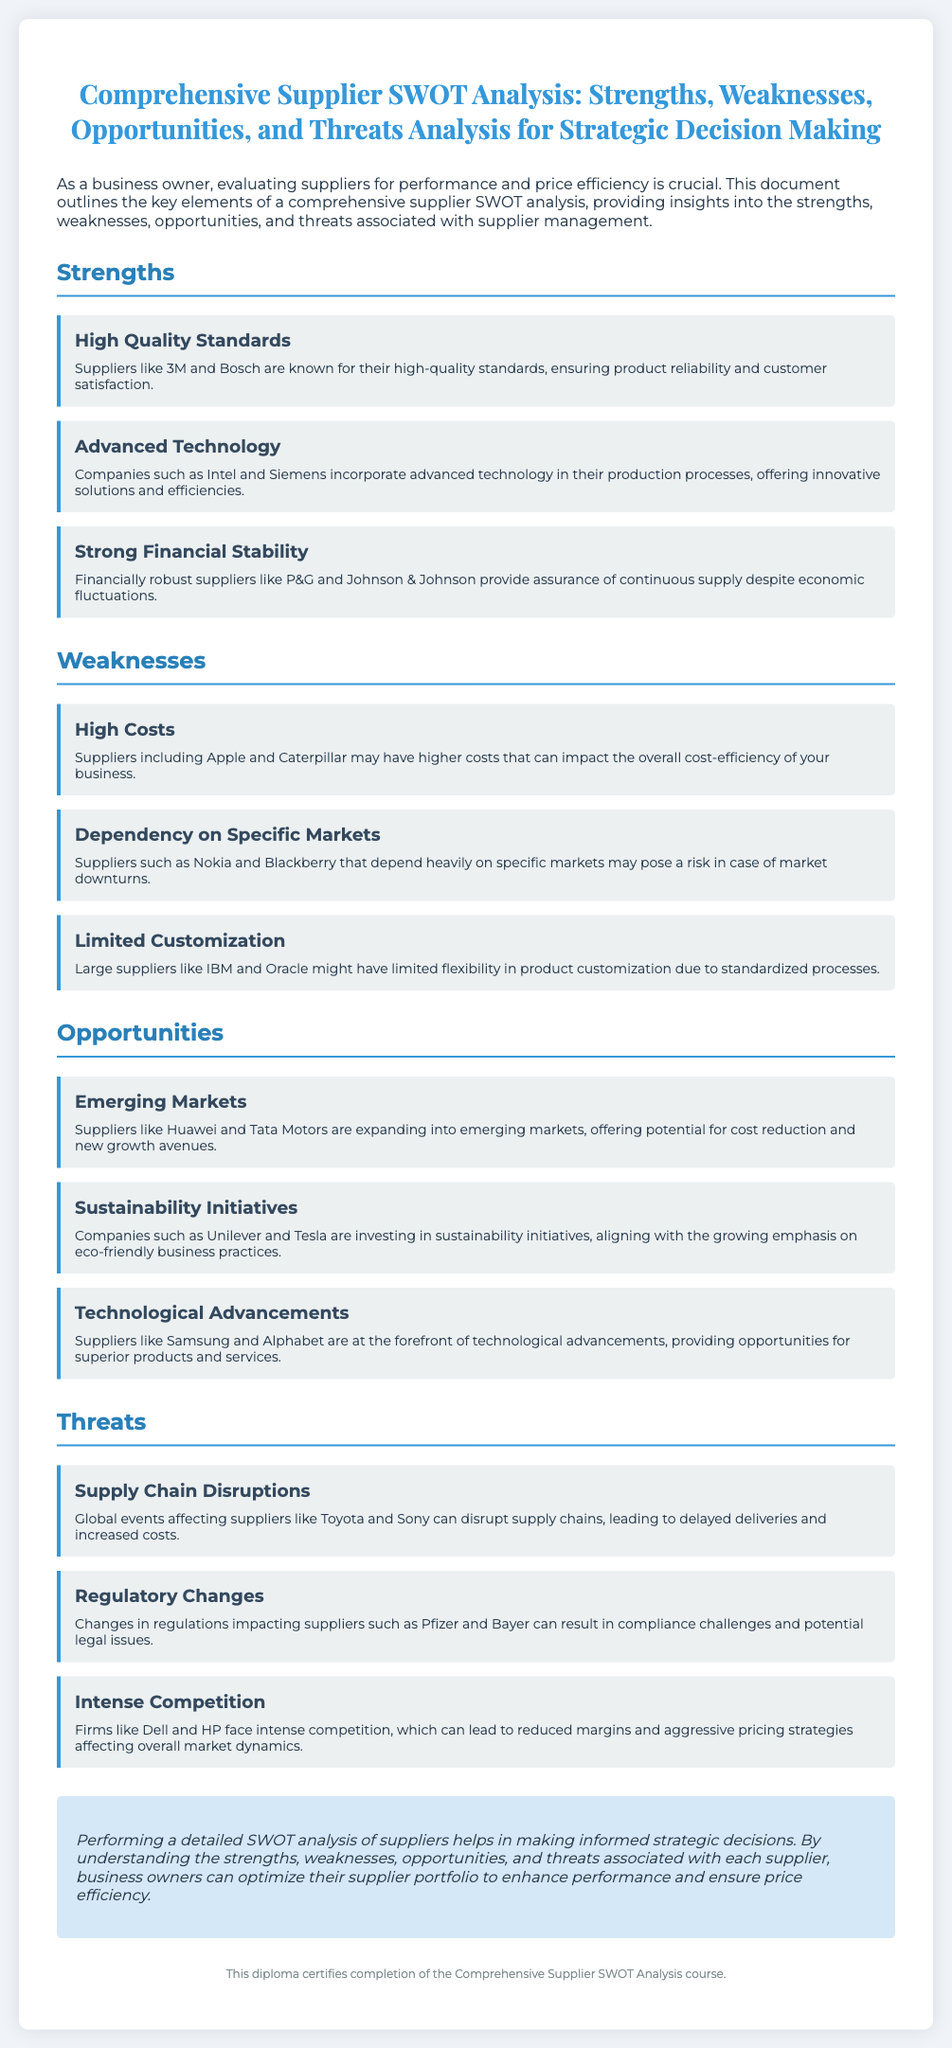what is the title of the document? The title provides the main subject of the diploma, focusing on supplier analysis.
Answer: Comprehensive Supplier SWOT Analysis: Strengths, Weaknesses, Opportunities, and Threats Analysis for Strategic Decision Making who is an example of a supplier known for high quality standards? This question refers to the information provided under the strengths section regarding quality suppliers.
Answer: 3M which weakness of suppliers relates to market dependency? This questions focuses on identifying a weakness that has been highlighted regarding market reliance.
Answer: Dependency on Specific Markets name a company involved in sustainability initiatives. The document lists companies that invest in sustainability, which is an opportunity for suppliers.
Answer: Unilever what is a threat related to global events affecting suppliers? This question pertains to the threats section, specifically mentioning supply chain disruptions.
Answer: Supply Chain Disruptions which supplier is associated with advanced technology? The strengths section includes suppliers noted for their technological advancements.
Answer: Intel how many main categories are discussed in the SWOT analysis? This question assesses understanding of the structure of the document regarding SWOT categories.
Answer: Four what kind of analysis does this diploma focus on for strategic decision-making? This focuses on the key type of analysis emphasized in the document.
Answer: SWOT analysis 